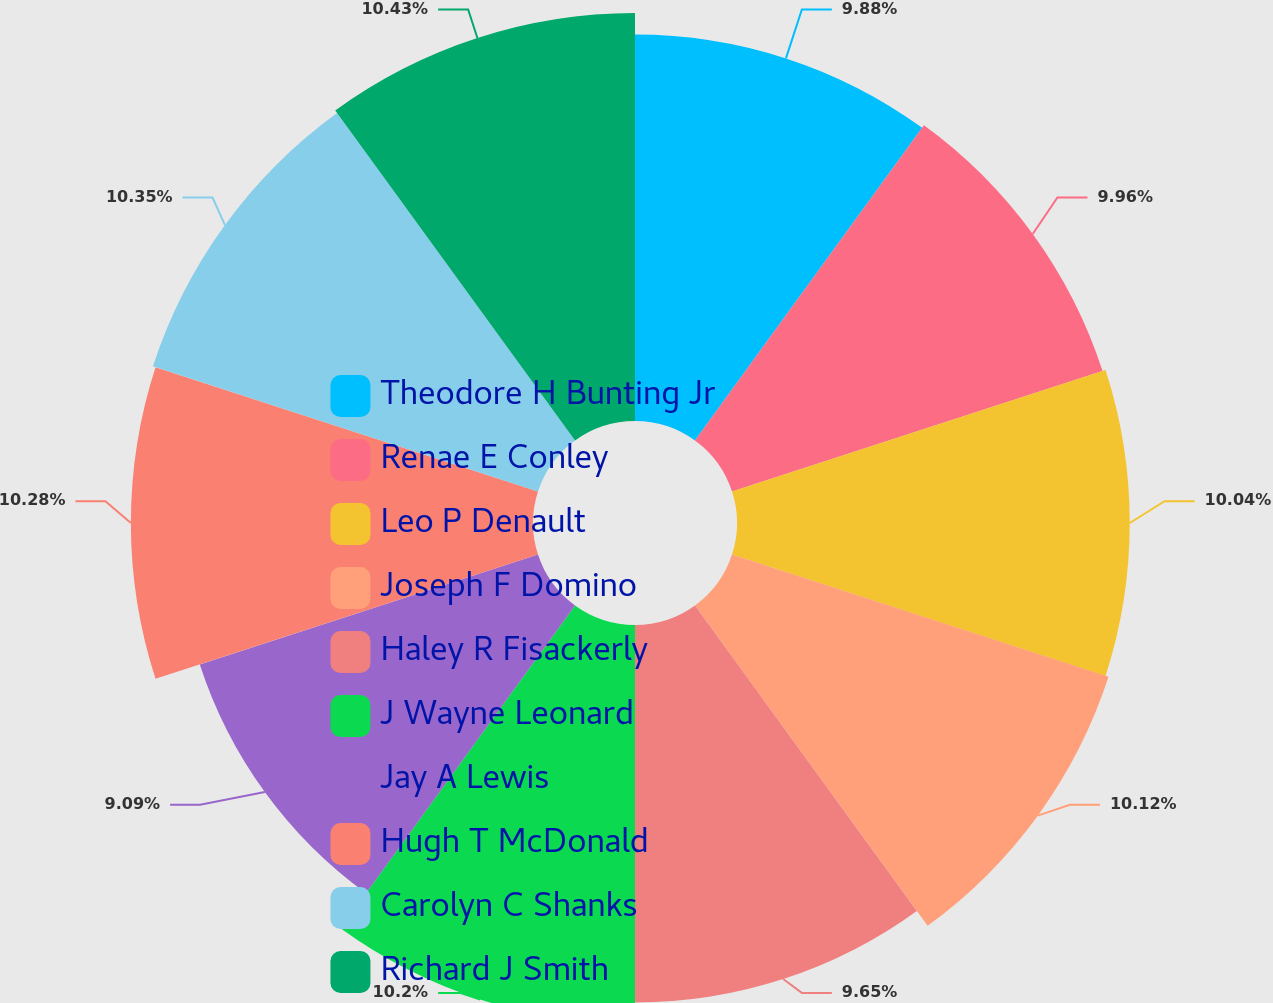Convert chart. <chart><loc_0><loc_0><loc_500><loc_500><pie_chart><fcel>Theodore H Bunting Jr<fcel>Renae E Conley<fcel>Leo P Denault<fcel>Joseph F Domino<fcel>Haley R Fisackerly<fcel>J Wayne Leonard<fcel>Jay A Lewis<fcel>Hugh T McDonald<fcel>Carolyn C Shanks<fcel>Richard J Smith<nl><fcel>9.88%<fcel>9.96%<fcel>10.04%<fcel>10.12%<fcel>9.65%<fcel>10.2%<fcel>9.09%<fcel>10.28%<fcel>10.35%<fcel>10.43%<nl></chart> 